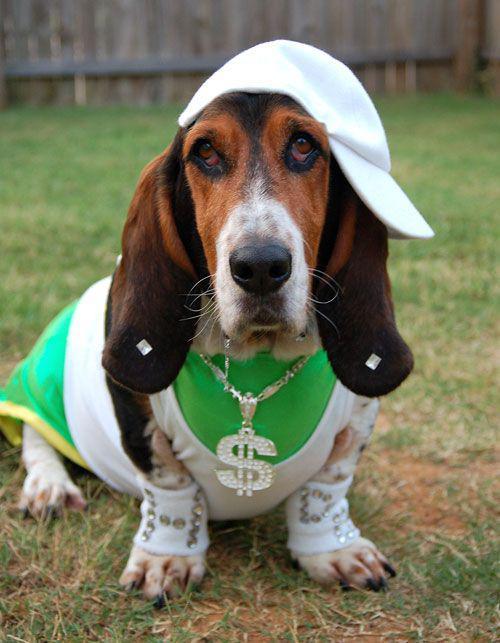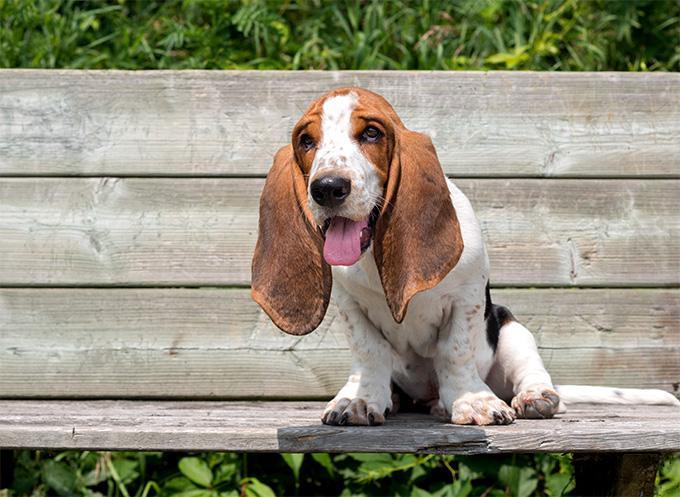The first image is the image on the left, the second image is the image on the right. Analyze the images presented: Is the assertion "The dog in the image on the left is sitting on grass." valid? Answer yes or no. Yes. The first image is the image on the left, the second image is the image on the right. Examine the images to the left and right. Is the description "One image shows a basset hound sitting on furniture made for humans." accurate? Answer yes or no. Yes. 